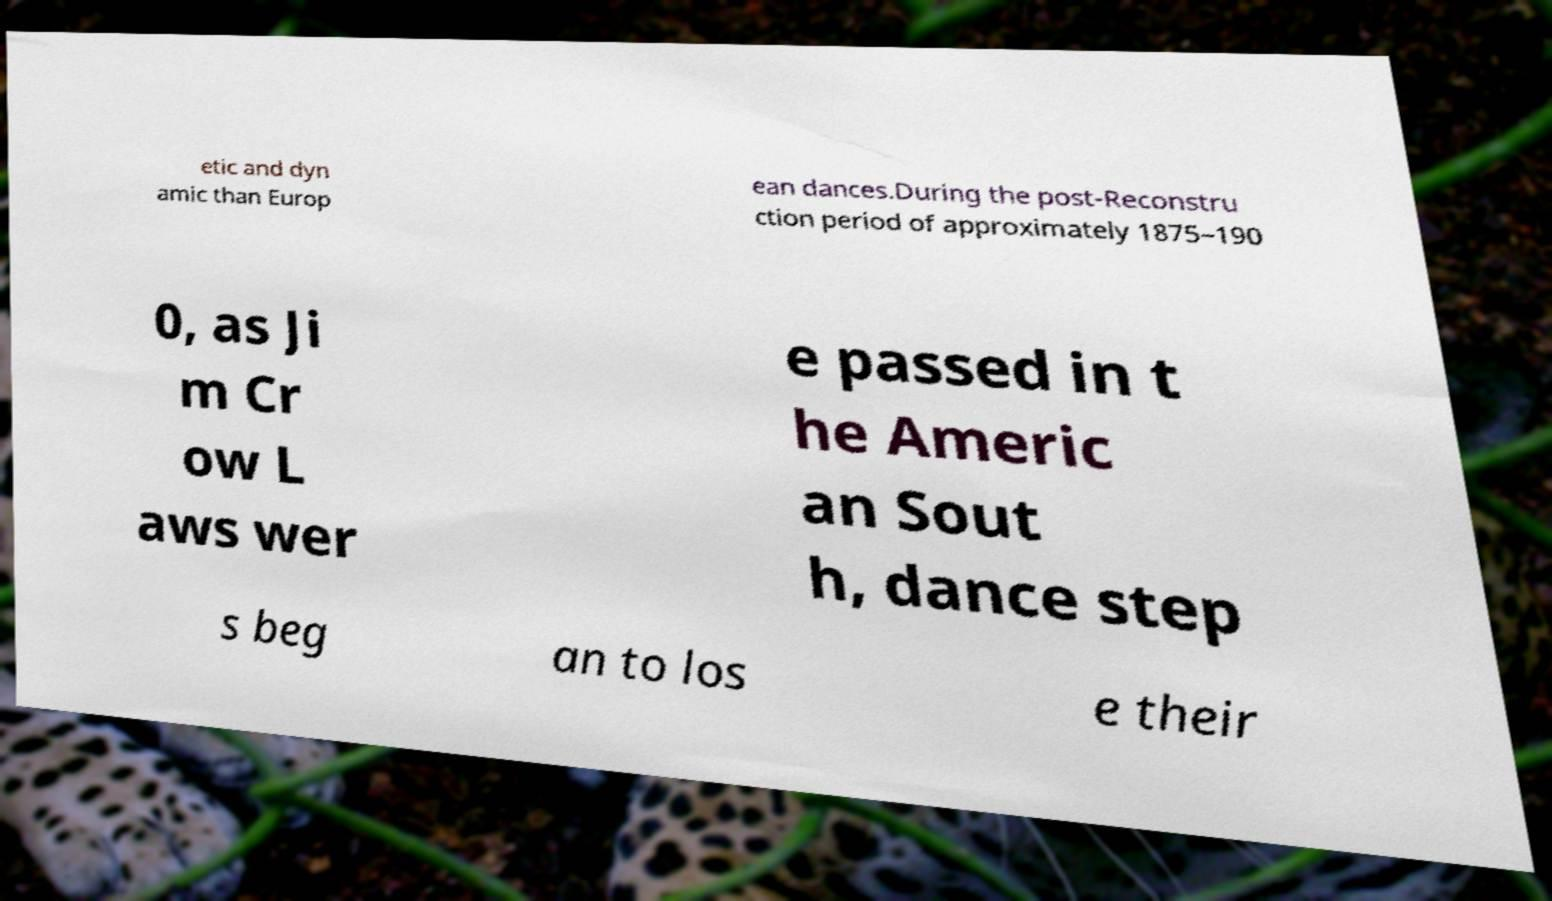Could you extract and type out the text from this image? etic and dyn amic than Europ ean dances.During the post-Reconstru ction period of approximately 1875–190 0, as Ji m Cr ow L aws wer e passed in t he Americ an Sout h, dance step s beg an to los e their 